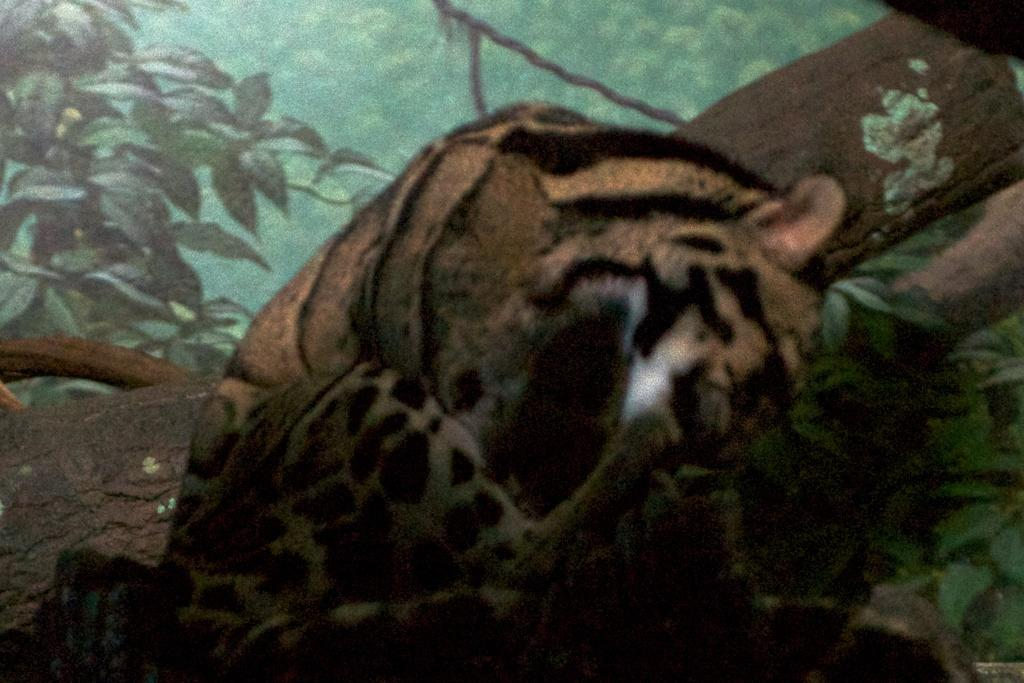What type of animal is in the image? There is a tiger in the image. What else can be seen in the image besides the tiger? There is a tree trunk and trees in the image. Can you describe the setting of the image? The image may depict a forest setting, given the presence of trees and a tree trunk. What type of chess piece is on top of the tree trunk in the image? There is no chess piece present in the image; it is a tiger, tree trunk, and trees. What type of crack can be seen on the tree trunk in the image? There is no crack visible on the tree trunk in the image. 